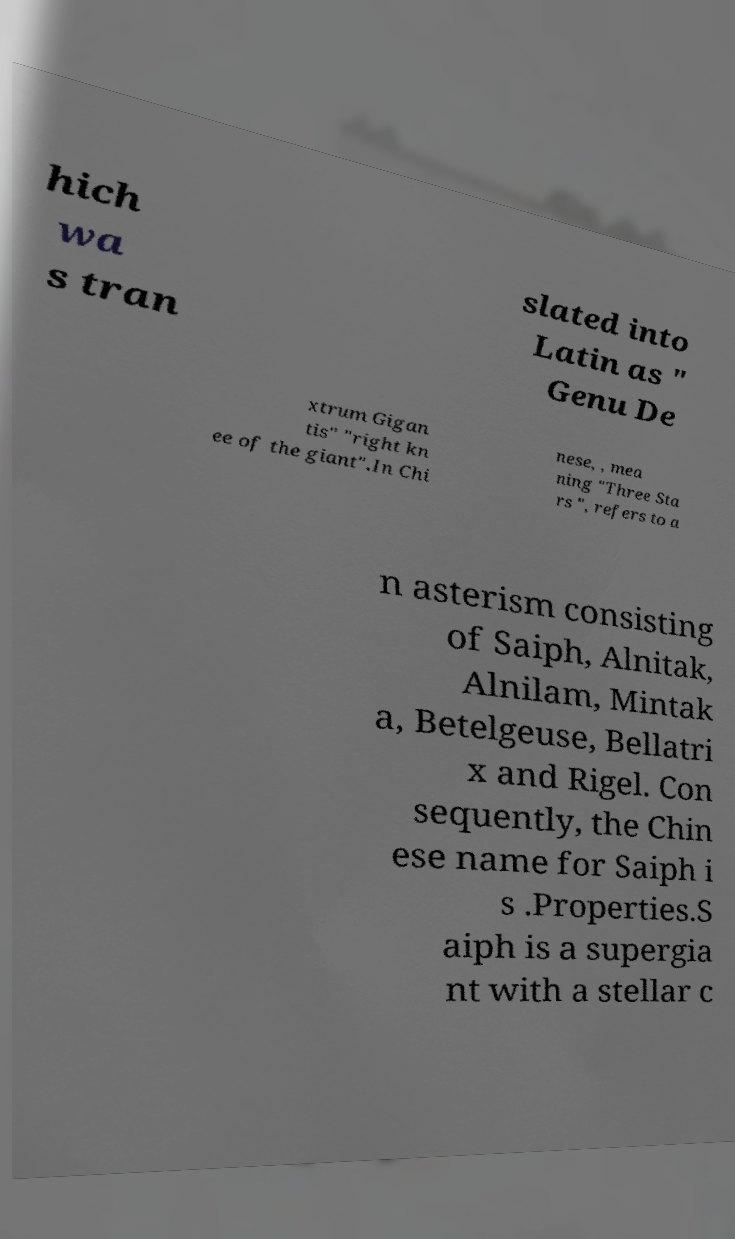For documentation purposes, I need the text within this image transcribed. Could you provide that? hich wa s tran slated into Latin as " Genu De xtrum Gigan tis" "right kn ee of the giant".In Chi nese, , mea ning "Three Sta rs ", refers to a n asterism consisting of Saiph, Alnitak, Alnilam, Mintak a, Betelgeuse, Bellatri x and Rigel. Con sequently, the Chin ese name for Saiph i s .Properties.S aiph is a supergia nt with a stellar c 